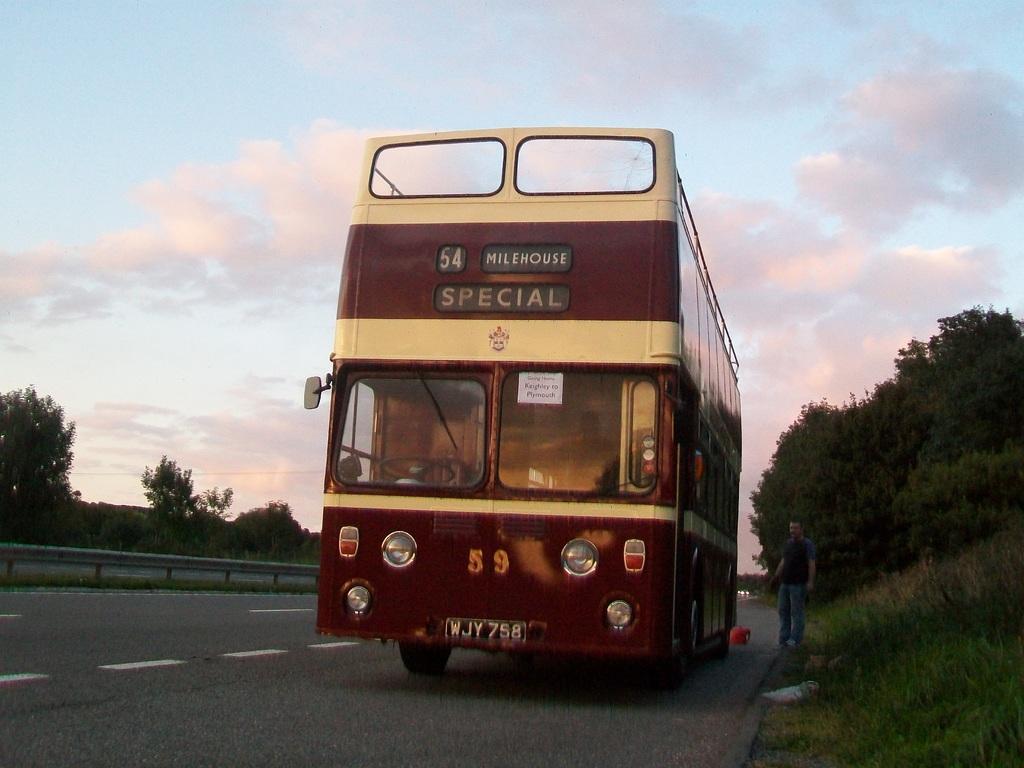Can you describe this image briefly? We can see the bus on the road, beside the bus there is a person standing. We can see grass and trees. In the background we can see the sky with clouds. 